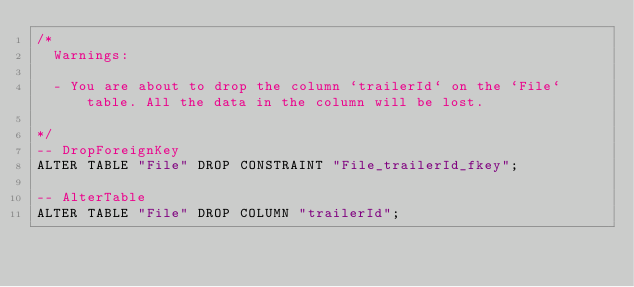<code> <loc_0><loc_0><loc_500><loc_500><_SQL_>/*
  Warnings:

  - You are about to drop the column `trailerId` on the `File` table. All the data in the column will be lost.

*/
-- DropForeignKey
ALTER TABLE "File" DROP CONSTRAINT "File_trailerId_fkey";

-- AlterTable
ALTER TABLE "File" DROP COLUMN "trailerId";
</code> 